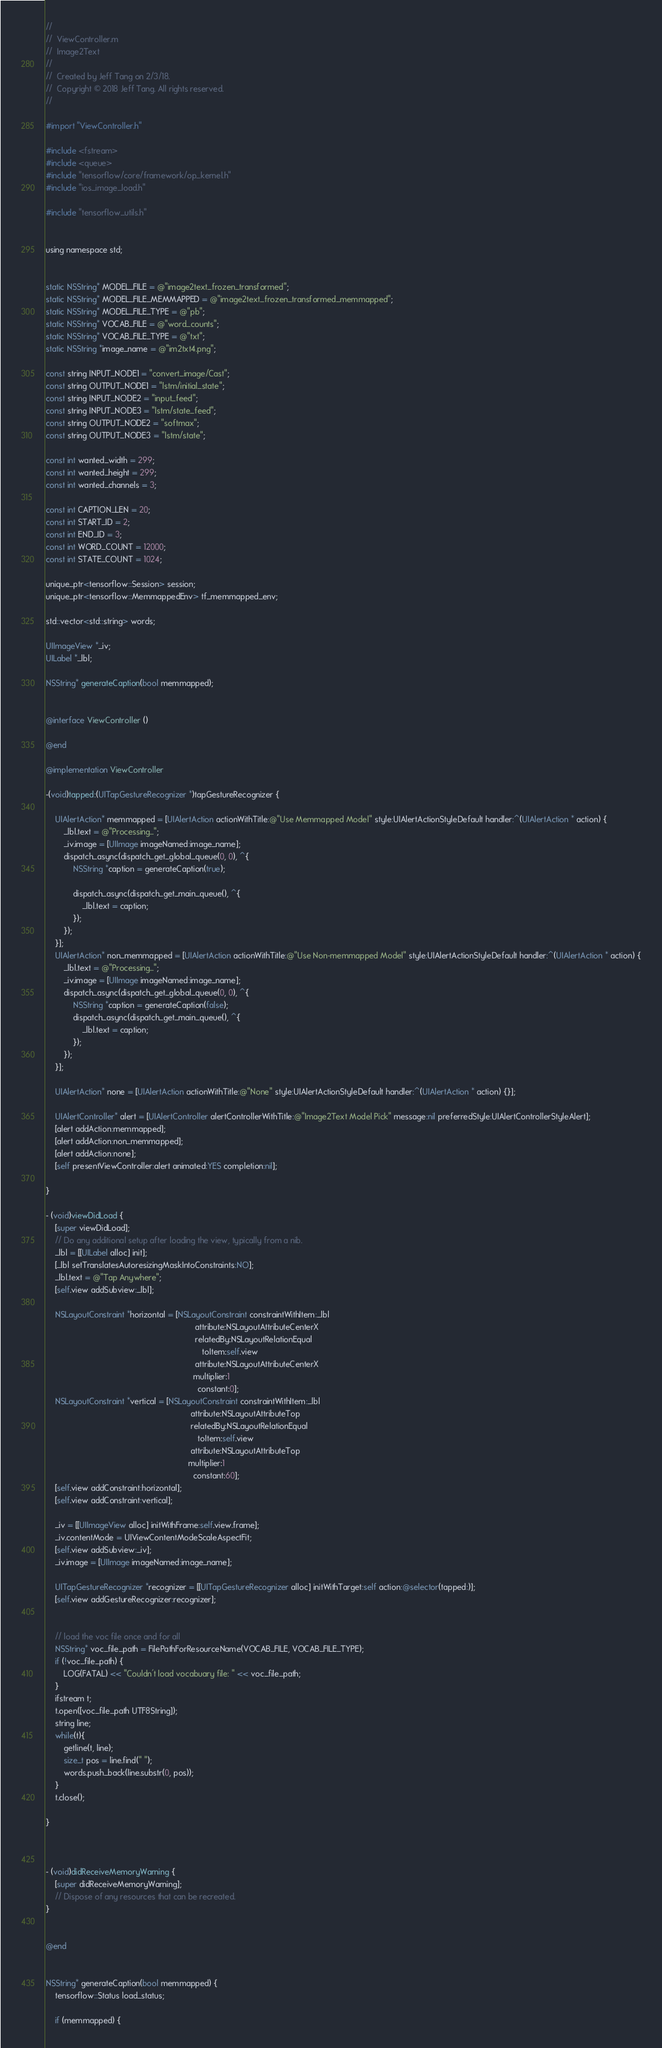Convert code to text. <code><loc_0><loc_0><loc_500><loc_500><_ObjectiveC_>//
//  ViewController.m
//  Image2Text
//
//  Created by Jeff Tang on 2/3/18.
//  Copyright © 2018 Jeff Tang. All rights reserved.
//

#import "ViewController.h"

#include <fstream>
#include <queue>
#include "tensorflow/core/framework/op_kernel.h"
#include "ios_image_load.h"

#include "tensorflow_utils.h"


using namespace std;


static NSString* MODEL_FILE = @"image2text_frozen_transformed";
static NSString* MODEL_FILE_MEMMAPPED = @"image2text_frozen_transformed_memmapped";
static NSString* MODEL_FILE_TYPE = @"pb";
static NSString* VOCAB_FILE = @"word_counts";
static NSString* VOCAB_FILE_TYPE = @"txt";
static NSString *image_name = @"im2txt4.png";

const string INPUT_NODE1 = "convert_image/Cast";
const string OUTPUT_NODE1 = "lstm/initial_state";
const string INPUT_NODE2 = "input_feed";
const string INPUT_NODE3 = "lstm/state_feed";
const string OUTPUT_NODE2 = "softmax";
const string OUTPUT_NODE3 = "lstm/state";

const int wanted_width = 299;
const int wanted_height = 299;
const int wanted_channels = 3;

const int CAPTION_LEN = 20;
const int START_ID = 2;
const int END_ID = 3;
const int WORD_COUNT = 12000;
const int STATE_COUNT = 1024;

unique_ptr<tensorflow::Session> session;
unique_ptr<tensorflow::MemmappedEnv> tf_memmapped_env;

std::vector<std::string> words;

UIImageView *_iv;
UILabel *_lbl;

NSString* generateCaption(bool memmapped);


@interface ViewController ()

@end

@implementation ViewController

-(void)tapped:(UITapGestureRecognizer *)tapGestureRecognizer {
    
    UIAlertAction* memmapped = [UIAlertAction actionWithTitle:@"Use Memmapped Model" style:UIAlertActionStyleDefault handler:^(UIAlertAction * action) {
        _lbl.text = @"Processing...";
        _iv.image = [UIImage imageNamed:image_name];
        dispatch_async(dispatch_get_global_queue(0, 0), ^{
            NSString *caption = generateCaption(true);
            
            dispatch_async(dispatch_get_main_queue(), ^{
                _lbl.text = caption;
            });
        });
    }];
    UIAlertAction* non_memmapped = [UIAlertAction actionWithTitle:@"Use Non-memmapped Model" style:UIAlertActionStyleDefault handler:^(UIAlertAction * action) {
        _lbl.text = @"Processing...";
        _iv.image = [UIImage imageNamed:image_name];
        dispatch_async(dispatch_get_global_queue(0, 0), ^{
            NSString *caption = generateCaption(false);
            dispatch_async(dispatch_get_main_queue(), ^{
                _lbl.text = caption;
            });
        });
    }];
    
    UIAlertAction* none = [UIAlertAction actionWithTitle:@"None" style:UIAlertActionStyleDefault handler:^(UIAlertAction * action) {}];
    
    UIAlertController* alert = [UIAlertController alertControllerWithTitle:@"Image2Text Model Pick" message:nil preferredStyle:UIAlertControllerStyleAlert];
    [alert addAction:memmapped];
    [alert addAction:non_memmapped];
    [alert addAction:none];
    [self presentViewController:alert animated:YES completion:nil];
    
}

- (void)viewDidLoad {
    [super viewDidLoad];
    // Do any additional setup after loading the view, typically from a nib.
    _lbl = [[UILabel alloc] init];
    [_lbl setTranslatesAutoresizingMaskIntoConstraints:NO];
    _lbl.text = @"Tap Anywhere";
    [self.view addSubview:_lbl];
    
    NSLayoutConstraint *horizontal = [NSLayoutConstraint constraintWithItem:_lbl
                                                                  attribute:NSLayoutAttributeCenterX
                                                                  relatedBy:NSLayoutRelationEqual
                                                                     toItem:self.view
                                                                  attribute:NSLayoutAttributeCenterX
                                                                 multiplier:1
                                                                   constant:0];
    NSLayoutConstraint *vertical = [NSLayoutConstraint constraintWithItem:_lbl
                                                                attribute:NSLayoutAttributeTop
                                                                relatedBy:NSLayoutRelationEqual
                                                                   toItem:self.view
                                                                attribute:NSLayoutAttributeTop
                                                               multiplier:1
                                                                 constant:60];
    [self.view addConstraint:horizontal];
    [self.view addConstraint:vertical];
    
    _iv = [[UIImageView alloc] initWithFrame:self.view.frame];
    _iv.contentMode = UIViewContentModeScaleAspectFit;
    [self.view addSubview:_iv];
    _iv.image = [UIImage imageNamed:image_name];
    
    UITapGestureRecognizer *recognizer = [[UITapGestureRecognizer alloc] initWithTarget:self action:@selector(tapped:)];
    [self.view addGestureRecognizer:recognizer];
    
    
    // load the voc file once and for all
    NSString* voc_file_path = FilePathForResourceName(VOCAB_FILE, VOCAB_FILE_TYPE);
    if (!voc_file_path) {
        LOG(FATAL) << "Couldn't load vocabuary file: " << voc_file_path;
    }
    ifstream t;
    t.open([voc_file_path UTF8String]);
    string line;
    while(t){
        getline(t, line);
        size_t pos = line.find(" ");
        words.push_back(line.substr(0, pos));
    }
    t.close();
    
}



- (void)didReceiveMemoryWarning {
    [super didReceiveMemoryWarning];
    // Dispose of any resources that can be recreated.
}


@end


NSString* generateCaption(bool memmapped) {
    tensorflow::Status load_status;
    
    if (memmapped) {</code> 